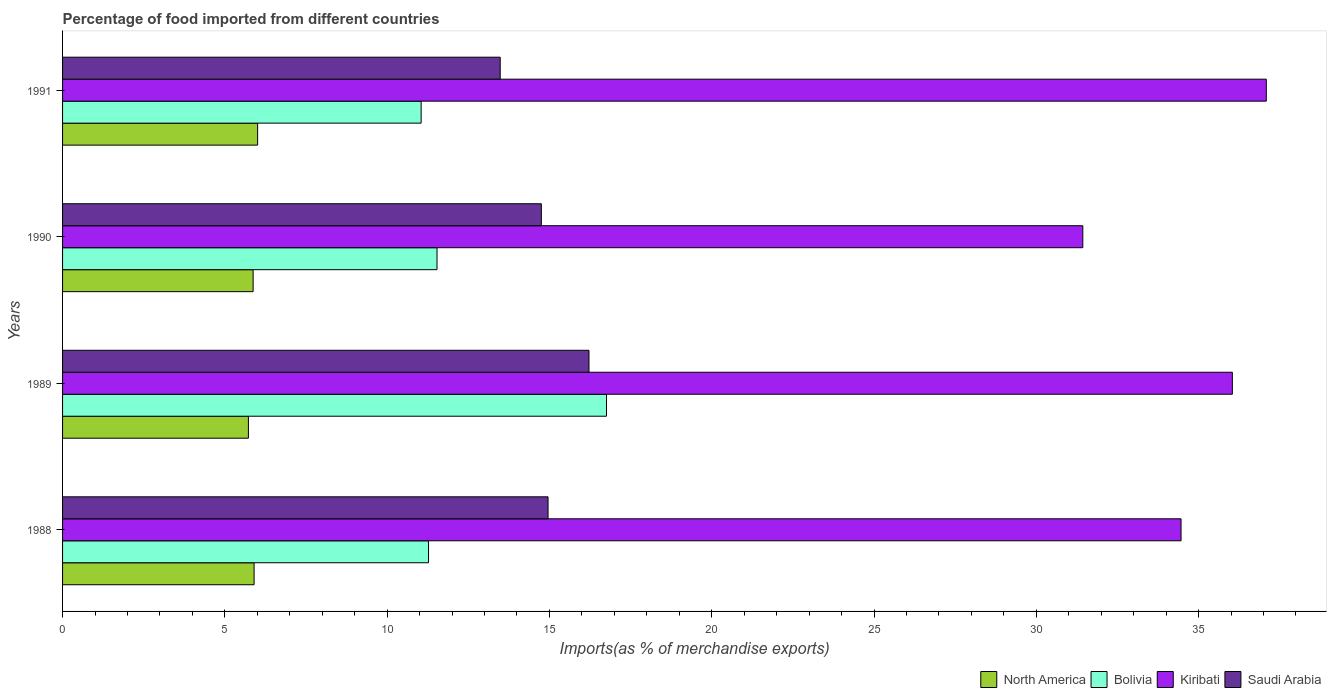How many groups of bars are there?
Your answer should be compact. 4. Are the number of bars on each tick of the Y-axis equal?
Ensure brevity in your answer.  Yes. How many bars are there on the 2nd tick from the top?
Provide a short and direct response. 4. What is the label of the 3rd group of bars from the top?
Offer a terse response. 1989. What is the percentage of imports to different countries in Saudi Arabia in 1990?
Make the answer very short. 14.75. Across all years, what is the maximum percentage of imports to different countries in Kiribati?
Your response must be concise. 37.09. Across all years, what is the minimum percentage of imports to different countries in Saudi Arabia?
Your response must be concise. 13.48. In which year was the percentage of imports to different countries in Saudi Arabia minimum?
Make the answer very short. 1991. What is the total percentage of imports to different countries in Saudi Arabia in the graph?
Your response must be concise. 59.41. What is the difference between the percentage of imports to different countries in Bolivia in 1989 and that in 1990?
Your answer should be very brief. 5.22. What is the difference between the percentage of imports to different countries in Kiribati in 1991 and the percentage of imports to different countries in Saudi Arabia in 1989?
Offer a very short reply. 20.87. What is the average percentage of imports to different countries in Bolivia per year?
Offer a terse response. 12.65. In the year 1988, what is the difference between the percentage of imports to different countries in Kiribati and percentage of imports to different countries in North America?
Offer a terse response. 28.56. What is the ratio of the percentage of imports to different countries in Kiribati in 1988 to that in 1989?
Offer a very short reply. 0.96. Is the percentage of imports to different countries in Saudi Arabia in 1988 less than that in 1991?
Make the answer very short. No. What is the difference between the highest and the second highest percentage of imports to different countries in North America?
Provide a succinct answer. 0.11. What is the difference between the highest and the lowest percentage of imports to different countries in North America?
Your answer should be very brief. 0.28. In how many years, is the percentage of imports to different countries in Bolivia greater than the average percentage of imports to different countries in Bolivia taken over all years?
Your answer should be compact. 1. Is it the case that in every year, the sum of the percentage of imports to different countries in North America and percentage of imports to different countries in Bolivia is greater than the sum of percentage of imports to different countries in Saudi Arabia and percentage of imports to different countries in Kiribati?
Provide a succinct answer. Yes. What does the 4th bar from the top in 1989 represents?
Your response must be concise. North America. How many bars are there?
Your answer should be compact. 16. What is the difference between two consecutive major ticks on the X-axis?
Ensure brevity in your answer.  5. How are the legend labels stacked?
Give a very brief answer. Horizontal. What is the title of the graph?
Make the answer very short. Percentage of food imported from different countries. What is the label or title of the X-axis?
Offer a very short reply. Imports(as % of merchandise exports). What is the Imports(as % of merchandise exports) in North America in 1988?
Your answer should be very brief. 5.9. What is the Imports(as % of merchandise exports) in Bolivia in 1988?
Keep it short and to the point. 11.27. What is the Imports(as % of merchandise exports) in Kiribati in 1988?
Make the answer very short. 34.46. What is the Imports(as % of merchandise exports) in Saudi Arabia in 1988?
Your answer should be compact. 14.96. What is the Imports(as % of merchandise exports) of North America in 1989?
Ensure brevity in your answer.  5.73. What is the Imports(as % of merchandise exports) of Bolivia in 1989?
Your answer should be very brief. 16.76. What is the Imports(as % of merchandise exports) in Kiribati in 1989?
Your answer should be very brief. 36.04. What is the Imports(as % of merchandise exports) in Saudi Arabia in 1989?
Offer a terse response. 16.22. What is the Imports(as % of merchandise exports) of North America in 1990?
Offer a very short reply. 5.87. What is the Imports(as % of merchandise exports) in Bolivia in 1990?
Ensure brevity in your answer.  11.54. What is the Imports(as % of merchandise exports) in Kiribati in 1990?
Your answer should be compact. 31.43. What is the Imports(as % of merchandise exports) in Saudi Arabia in 1990?
Your answer should be compact. 14.75. What is the Imports(as % of merchandise exports) of North America in 1991?
Offer a very short reply. 6.01. What is the Imports(as % of merchandise exports) in Bolivia in 1991?
Your answer should be very brief. 11.05. What is the Imports(as % of merchandise exports) in Kiribati in 1991?
Provide a succinct answer. 37.09. What is the Imports(as % of merchandise exports) in Saudi Arabia in 1991?
Offer a very short reply. 13.48. Across all years, what is the maximum Imports(as % of merchandise exports) of North America?
Keep it short and to the point. 6.01. Across all years, what is the maximum Imports(as % of merchandise exports) in Bolivia?
Offer a terse response. 16.76. Across all years, what is the maximum Imports(as % of merchandise exports) in Kiribati?
Provide a succinct answer. 37.09. Across all years, what is the maximum Imports(as % of merchandise exports) of Saudi Arabia?
Make the answer very short. 16.22. Across all years, what is the minimum Imports(as % of merchandise exports) in North America?
Offer a terse response. 5.73. Across all years, what is the minimum Imports(as % of merchandise exports) in Bolivia?
Keep it short and to the point. 11.05. Across all years, what is the minimum Imports(as % of merchandise exports) of Kiribati?
Ensure brevity in your answer.  31.43. Across all years, what is the minimum Imports(as % of merchandise exports) in Saudi Arabia?
Offer a very short reply. 13.48. What is the total Imports(as % of merchandise exports) of North America in the graph?
Provide a succinct answer. 23.51. What is the total Imports(as % of merchandise exports) in Bolivia in the graph?
Your answer should be very brief. 50.62. What is the total Imports(as % of merchandise exports) in Kiribati in the graph?
Give a very brief answer. 139.02. What is the total Imports(as % of merchandise exports) in Saudi Arabia in the graph?
Keep it short and to the point. 59.41. What is the difference between the Imports(as % of merchandise exports) of North America in 1988 and that in 1989?
Ensure brevity in your answer.  0.17. What is the difference between the Imports(as % of merchandise exports) in Bolivia in 1988 and that in 1989?
Keep it short and to the point. -5.48. What is the difference between the Imports(as % of merchandise exports) of Kiribati in 1988 and that in 1989?
Your response must be concise. -1.58. What is the difference between the Imports(as % of merchandise exports) of Saudi Arabia in 1988 and that in 1989?
Your answer should be compact. -1.26. What is the difference between the Imports(as % of merchandise exports) of Bolivia in 1988 and that in 1990?
Offer a terse response. -0.26. What is the difference between the Imports(as % of merchandise exports) in Kiribati in 1988 and that in 1990?
Keep it short and to the point. 3.03. What is the difference between the Imports(as % of merchandise exports) in Saudi Arabia in 1988 and that in 1990?
Offer a terse response. 0.21. What is the difference between the Imports(as % of merchandise exports) in North America in 1988 and that in 1991?
Provide a short and direct response. -0.11. What is the difference between the Imports(as % of merchandise exports) of Bolivia in 1988 and that in 1991?
Your answer should be compact. 0.23. What is the difference between the Imports(as % of merchandise exports) in Kiribati in 1988 and that in 1991?
Ensure brevity in your answer.  -2.63. What is the difference between the Imports(as % of merchandise exports) in Saudi Arabia in 1988 and that in 1991?
Provide a succinct answer. 1.47. What is the difference between the Imports(as % of merchandise exports) of North America in 1989 and that in 1990?
Give a very brief answer. -0.14. What is the difference between the Imports(as % of merchandise exports) in Bolivia in 1989 and that in 1990?
Give a very brief answer. 5.22. What is the difference between the Imports(as % of merchandise exports) of Kiribati in 1989 and that in 1990?
Keep it short and to the point. 4.61. What is the difference between the Imports(as % of merchandise exports) in Saudi Arabia in 1989 and that in 1990?
Provide a short and direct response. 1.47. What is the difference between the Imports(as % of merchandise exports) of North America in 1989 and that in 1991?
Your answer should be compact. -0.28. What is the difference between the Imports(as % of merchandise exports) of Bolivia in 1989 and that in 1991?
Offer a very short reply. 5.71. What is the difference between the Imports(as % of merchandise exports) of Kiribati in 1989 and that in 1991?
Your answer should be very brief. -1.05. What is the difference between the Imports(as % of merchandise exports) of Saudi Arabia in 1989 and that in 1991?
Give a very brief answer. 2.73. What is the difference between the Imports(as % of merchandise exports) in North America in 1990 and that in 1991?
Your answer should be very brief. -0.14. What is the difference between the Imports(as % of merchandise exports) of Bolivia in 1990 and that in 1991?
Offer a very short reply. 0.49. What is the difference between the Imports(as % of merchandise exports) in Kiribati in 1990 and that in 1991?
Your answer should be very brief. -5.65. What is the difference between the Imports(as % of merchandise exports) of Saudi Arabia in 1990 and that in 1991?
Ensure brevity in your answer.  1.27. What is the difference between the Imports(as % of merchandise exports) of North America in 1988 and the Imports(as % of merchandise exports) of Bolivia in 1989?
Provide a short and direct response. -10.86. What is the difference between the Imports(as % of merchandise exports) in North America in 1988 and the Imports(as % of merchandise exports) in Kiribati in 1989?
Your response must be concise. -30.14. What is the difference between the Imports(as % of merchandise exports) in North America in 1988 and the Imports(as % of merchandise exports) in Saudi Arabia in 1989?
Provide a short and direct response. -10.32. What is the difference between the Imports(as % of merchandise exports) of Bolivia in 1988 and the Imports(as % of merchandise exports) of Kiribati in 1989?
Offer a very short reply. -24.76. What is the difference between the Imports(as % of merchandise exports) in Bolivia in 1988 and the Imports(as % of merchandise exports) in Saudi Arabia in 1989?
Provide a succinct answer. -4.94. What is the difference between the Imports(as % of merchandise exports) of Kiribati in 1988 and the Imports(as % of merchandise exports) of Saudi Arabia in 1989?
Ensure brevity in your answer.  18.24. What is the difference between the Imports(as % of merchandise exports) of North America in 1988 and the Imports(as % of merchandise exports) of Bolivia in 1990?
Your answer should be very brief. -5.64. What is the difference between the Imports(as % of merchandise exports) of North America in 1988 and the Imports(as % of merchandise exports) of Kiribati in 1990?
Offer a terse response. -25.53. What is the difference between the Imports(as % of merchandise exports) in North America in 1988 and the Imports(as % of merchandise exports) in Saudi Arabia in 1990?
Offer a very short reply. -8.85. What is the difference between the Imports(as % of merchandise exports) of Bolivia in 1988 and the Imports(as % of merchandise exports) of Kiribati in 1990?
Offer a very short reply. -20.16. What is the difference between the Imports(as % of merchandise exports) of Bolivia in 1988 and the Imports(as % of merchandise exports) of Saudi Arabia in 1990?
Provide a succinct answer. -3.48. What is the difference between the Imports(as % of merchandise exports) in Kiribati in 1988 and the Imports(as % of merchandise exports) in Saudi Arabia in 1990?
Provide a succinct answer. 19.71. What is the difference between the Imports(as % of merchandise exports) in North America in 1988 and the Imports(as % of merchandise exports) in Bolivia in 1991?
Keep it short and to the point. -5.15. What is the difference between the Imports(as % of merchandise exports) in North America in 1988 and the Imports(as % of merchandise exports) in Kiribati in 1991?
Make the answer very short. -31.18. What is the difference between the Imports(as % of merchandise exports) in North America in 1988 and the Imports(as % of merchandise exports) in Saudi Arabia in 1991?
Provide a succinct answer. -7.58. What is the difference between the Imports(as % of merchandise exports) in Bolivia in 1988 and the Imports(as % of merchandise exports) in Kiribati in 1991?
Offer a terse response. -25.81. What is the difference between the Imports(as % of merchandise exports) in Bolivia in 1988 and the Imports(as % of merchandise exports) in Saudi Arabia in 1991?
Your answer should be very brief. -2.21. What is the difference between the Imports(as % of merchandise exports) in Kiribati in 1988 and the Imports(as % of merchandise exports) in Saudi Arabia in 1991?
Ensure brevity in your answer.  20.98. What is the difference between the Imports(as % of merchandise exports) of North America in 1989 and the Imports(as % of merchandise exports) of Bolivia in 1990?
Your answer should be very brief. -5.81. What is the difference between the Imports(as % of merchandise exports) of North America in 1989 and the Imports(as % of merchandise exports) of Kiribati in 1990?
Ensure brevity in your answer.  -25.71. What is the difference between the Imports(as % of merchandise exports) of North America in 1989 and the Imports(as % of merchandise exports) of Saudi Arabia in 1990?
Your answer should be very brief. -9.03. What is the difference between the Imports(as % of merchandise exports) of Bolivia in 1989 and the Imports(as % of merchandise exports) of Kiribati in 1990?
Give a very brief answer. -14.67. What is the difference between the Imports(as % of merchandise exports) in Bolivia in 1989 and the Imports(as % of merchandise exports) in Saudi Arabia in 1990?
Your response must be concise. 2.01. What is the difference between the Imports(as % of merchandise exports) in Kiribati in 1989 and the Imports(as % of merchandise exports) in Saudi Arabia in 1990?
Provide a succinct answer. 21.29. What is the difference between the Imports(as % of merchandise exports) of North America in 1989 and the Imports(as % of merchandise exports) of Bolivia in 1991?
Provide a succinct answer. -5.32. What is the difference between the Imports(as % of merchandise exports) in North America in 1989 and the Imports(as % of merchandise exports) in Kiribati in 1991?
Provide a short and direct response. -31.36. What is the difference between the Imports(as % of merchandise exports) of North America in 1989 and the Imports(as % of merchandise exports) of Saudi Arabia in 1991?
Ensure brevity in your answer.  -7.76. What is the difference between the Imports(as % of merchandise exports) of Bolivia in 1989 and the Imports(as % of merchandise exports) of Kiribati in 1991?
Your response must be concise. -20.33. What is the difference between the Imports(as % of merchandise exports) of Bolivia in 1989 and the Imports(as % of merchandise exports) of Saudi Arabia in 1991?
Provide a succinct answer. 3.27. What is the difference between the Imports(as % of merchandise exports) in Kiribati in 1989 and the Imports(as % of merchandise exports) in Saudi Arabia in 1991?
Make the answer very short. 22.56. What is the difference between the Imports(as % of merchandise exports) of North America in 1990 and the Imports(as % of merchandise exports) of Bolivia in 1991?
Make the answer very short. -5.18. What is the difference between the Imports(as % of merchandise exports) in North America in 1990 and the Imports(as % of merchandise exports) in Kiribati in 1991?
Your answer should be very brief. -31.21. What is the difference between the Imports(as % of merchandise exports) of North America in 1990 and the Imports(as % of merchandise exports) of Saudi Arabia in 1991?
Make the answer very short. -7.61. What is the difference between the Imports(as % of merchandise exports) of Bolivia in 1990 and the Imports(as % of merchandise exports) of Kiribati in 1991?
Provide a succinct answer. -25.55. What is the difference between the Imports(as % of merchandise exports) of Bolivia in 1990 and the Imports(as % of merchandise exports) of Saudi Arabia in 1991?
Your response must be concise. -1.95. What is the difference between the Imports(as % of merchandise exports) in Kiribati in 1990 and the Imports(as % of merchandise exports) in Saudi Arabia in 1991?
Make the answer very short. 17.95. What is the average Imports(as % of merchandise exports) in North America per year?
Provide a short and direct response. 5.88. What is the average Imports(as % of merchandise exports) in Bolivia per year?
Offer a very short reply. 12.65. What is the average Imports(as % of merchandise exports) in Kiribati per year?
Your response must be concise. 34.75. What is the average Imports(as % of merchandise exports) of Saudi Arabia per year?
Offer a terse response. 14.85. In the year 1988, what is the difference between the Imports(as % of merchandise exports) in North America and Imports(as % of merchandise exports) in Bolivia?
Give a very brief answer. -5.37. In the year 1988, what is the difference between the Imports(as % of merchandise exports) of North America and Imports(as % of merchandise exports) of Kiribati?
Your answer should be compact. -28.56. In the year 1988, what is the difference between the Imports(as % of merchandise exports) of North America and Imports(as % of merchandise exports) of Saudi Arabia?
Provide a short and direct response. -9.06. In the year 1988, what is the difference between the Imports(as % of merchandise exports) in Bolivia and Imports(as % of merchandise exports) in Kiribati?
Your response must be concise. -23.18. In the year 1988, what is the difference between the Imports(as % of merchandise exports) of Bolivia and Imports(as % of merchandise exports) of Saudi Arabia?
Provide a short and direct response. -3.68. In the year 1988, what is the difference between the Imports(as % of merchandise exports) in Kiribati and Imports(as % of merchandise exports) in Saudi Arabia?
Keep it short and to the point. 19.5. In the year 1989, what is the difference between the Imports(as % of merchandise exports) in North America and Imports(as % of merchandise exports) in Bolivia?
Make the answer very short. -11.03. In the year 1989, what is the difference between the Imports(as % of merchandise exports) of North America and Imports(as % of merchandise exports) of Kiribati?
Offer a very short reply. -30.31. In the year 1989, what is the difference between the Imports(as % of merchandise exports) of North America and Imports(as % of merchandise exports) of Saudi Arabia?
Make the answer very short. -10.49. In the year 1989, what is the difference between the Imports(as % of merchandise exports) in Bolivia and Imports(as % of merchandise exports) in Kiribati?
Keep it short and to the point. -19.28. In the year 1989, what is the difference between the Imports(as % of merchandise exports) in Bolivia and Imports(as % of merchandise exports) in Saudi Arabia?
Make the answer very short. 0.54. In the year 1989, what is the difference between the Imports(as % of merchandise exports) of Kiribati and Imports(as % of merchandise exports) of Saudi Arabia?
Provide a short and direct response. 19.82. In the year 1990, what is the difference between the Imports(as % of merchandise exports) in North America and Imports(as % of merchandise exports) in Bolivia?
Give a very brief answer. -5.67. In the year 1990, what is the difference between the Imports(as % of merchandise exports) of North America and Imports(as % of merchandise exports) of Kiribati?
Make the answer very short. -25.56. In the year 1990, what is the difference between the Imports(as % of merchandise exports) of North America and Imports(as % of merchandise exports) of Saudi Arabia?
Offer a terse response. -8.88. In the year 1990, what is the difference between the Imports(as % of merchandise exports) of Bolivia and Imports(as % of merchandise exports) of Kiribati?
Make the answer very short. -19.9. In the year 1990, what is the difference between the Imports(as % of merchandise exports) of Bolivia and Imports(as % of merchandise exports) of Saudi Arabia?
Your answer should be very brief. -3.21. In the year 1990, what is the difference between the Imports(as % of merchandise exports) of Kiribati and Imports(as % of merchandise exports) of Saudi Arabia?
Give a very brief answer. 16.68. In the year 1991, what is the difference between the Imports(as % of merchandise exports) in North America and Imports(as % of merchandise exports) in Bolivia?
Provide a succinct answer. -5.04. In the year 1991, what is the difference between the Imports(as % of merchandise exports) in North America and Imports(as % of merchandise exports) in Kiribati?
Make the answer very short. -31.08. In the year 1991, what is the difference between the Imports(as % of merchandise exports) in North America and Imports(as % of merchandise exports) in Saudi Arabia?
Your answer should be compact. -7.47. In the year 1991, what is the difference between the Imports(as % of merchandise exports) in Bolivia and Imports(as % of merchandise exports) in Kiribati?
Your answer should be very brief. -26.04. In the year 1991, what is the difference between the Imports(as % of merchandise exports) of Bolivia and Imports(as % of merchandise exports) of Saudi Arabia?
Your response must be concise. -2.44. In the year 1991, what is the difference between the Imports(as % of merchandise exports) in Kiribati and Imports(as % of merchandise exports) in Saudi Arabia?
Your response must be concise. 23.6. What is the ratio of the Imports(as % of merchandise exports) in North America in 1988 to that in 1989?
Offer a very short reply. 1.03. What is the ratio of the Imports(as % of merchandise exports) of Bolivia in 1988 to that in 1989?
Provide a succinct answer. 0.67. What is the ratio of the Imports(as % of merchandise exports) of Kiribati in 1988 to that in 1989?
Give a very brief answer. 0.96. What is the ratio of the Imports(as % of merchandise exports) in Saudi Arabia in 1988 to that in 1989?
Give a very brief answer. 0.92. What is the ratio of the Imports(as % of merchandise exports) of North America in 1988 to that in 1990?
Give a very brief answer. 1.01. What is the ratio of the Imports(as % of merchandise exports) of Bolivia in 1988 to that in 1990?
Give a very brief answer. 0.98. What is the ratio of the Imports(as % of merchandise exports) of Kiribati in 1988 to that in 1990?
Your answer should be very brief. 1.1. What is the ratio of the Imports(as % of merchandise exports) of North America in 1988 to that in 1991?
Ensure brevity in your answer.  0.98. What is the ratio of the Imports(as % of merchandise exports) of Bolivia in 1988 to that in 1991?
Offer a terse response. 1.02. What is the ratio of the Imports(as % of merchandise exports) of Kiribati in 1988 to that in 1991?
Give a very brief answer. 0.93. What is the ratio of the Imports(as % of merchandise exports) of Saudi Arabia in 1988 to that in 1991?
Your response must be concise. 1.11. What is the ratio of the Imports(as % of merchandise exports) of North America in 1989 to that in 1990?
Keep it short and to the point. 0.98. What is the ratio of the Imports(as % of merchandise exports) of Bolivia in 1989 to that in 1990?
Provide a succinct answer. 1.45. What is the ratio of the Imports(as % of merchandise exports) of Kiribati in 1989 to that in 1990?
Give a very brief answer. 1.15. What is the ratio of the Imports(as % of merchandise exports) of Saudi Arabia in 1989 to that in 1990?
Provide a succinct answer. 1.1. What is the ratio of the Imports(as % of merchandise exports) in North America in 1989 to that in 1991?
Your answer should be compact. 0.95. What is the ratio of the Imports(as % of merchandise exports) of Bolivia in 1989 to that in 1991?
Your answer should be very brief. 1.52. What is the ratio of the Imports(as % of merchandise exports) in Kiribati in 1989 to that in 1991?
Provide a succinct answer. 0.97. What is the ratio of the Imports(as % of merchandise exports) in Saudi Arabia in 1989 to that in 1991?
Offer a terse response. 1.2. What is the ratio of the Imports(as % of merchandise exports) in North America in 1990 to that in 1991?
Provide a short and direct response. 0.98. What is the ratio of the Imports(as % of merchandise exports) in Bolivia in 1990 to that in 1991?
Provide a short and direct response. 1.04. What is the ratio of the Imports(as % of merchandise exports) in Kiribati in 1990 to that in 1991?
Offer a very short reply. 0.85. What is the ratio of the Imports(as % of merchandise exports) in Saudi Arabia in 1990 to that in 1991?
Your answer should be compact. 1.09. What is the difference between the highest and the second highest Imports(as % of merchandise exports) of North America?
Provide a short and direct response. 0.11. What is the difference between the highest and the second highest Imports(as % of merchandise exports) in Bolivia?
Your answer should be very brief. 5.22. What is the difference between the highest and the second highest Imports(as % of merchandise exports) of Kiribati?
Keep it short and to the point. 1.05. What is the difference between the highest and the second highest Imports(as % of merchandise exports) of Saudi Arabia?
Make the answer very short. 1.26. What is the difference between the highest and the lowest Imports(as % of merchandise exports) of North America?
Give a very brief answer. 0.28. What is the difference between the highest and the lowest Imports(as % of merchandise exports) of Bolivia?
Your response must be concise. 5.71. What is the difference between the highest and the lowest Imports(as % of merchandise exports) in Kiribati?
Make the answer very short. 5.65. What is the difference between the highest and the lowest Imports(as % of merchandise exports) in Saudi Arabia?
Your answer should be compact. 2.73. 